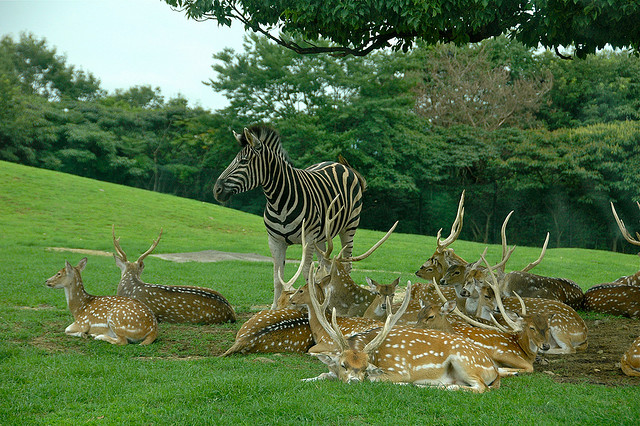<image>What country are the animals in? I am not sure what country the animals in, it could be either United States or Africa. What country are the animals in? I don't know what country the animals are in. It can be United States, Africa, or USA. 